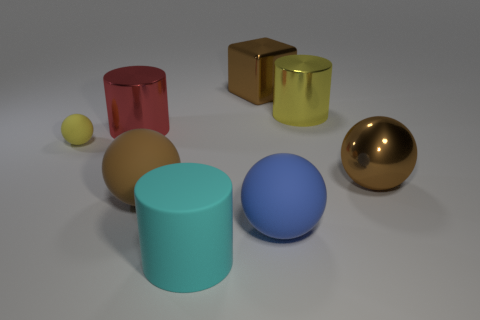There is a shiny thing that is the same color as the large cube; what size is it?
Keep it short and to the point. Large. There is a big cylinder that is behind the red metal object; is its color the same as the small matte thing?
Keep it short and to the point. Yes. The yellow thing to the right of the large brown ball that is left of the big metal thing that is in front of the yellow ball is what shape?
Provide a short and direct response. Cylinder. Are there more balls that are right of the big cyan matte object than small brown spheres?
Give a very brief answer. Yes. There is a big blue matte object right of the brown block; is its shape the same as the small thing?
Your response must be concise. Yes. There is a brown thing on the left side of the rubber cylinder; what is it made of?
Keep it short and to the point. Rubber. How many brown objects are the same shape as the big blue thing?
Keep it short and to the point. 2. What material is the big cylinder in front of the red thing behind the small ball made of?
Keep it short and to the point. Rubber. What shape is the big metal thing that is the same color as the big shiny sphere?
Offer a very short reply. Cube. Is there a red cylinder made of the same material as the large red thing?
Your answer should be compact. No. 